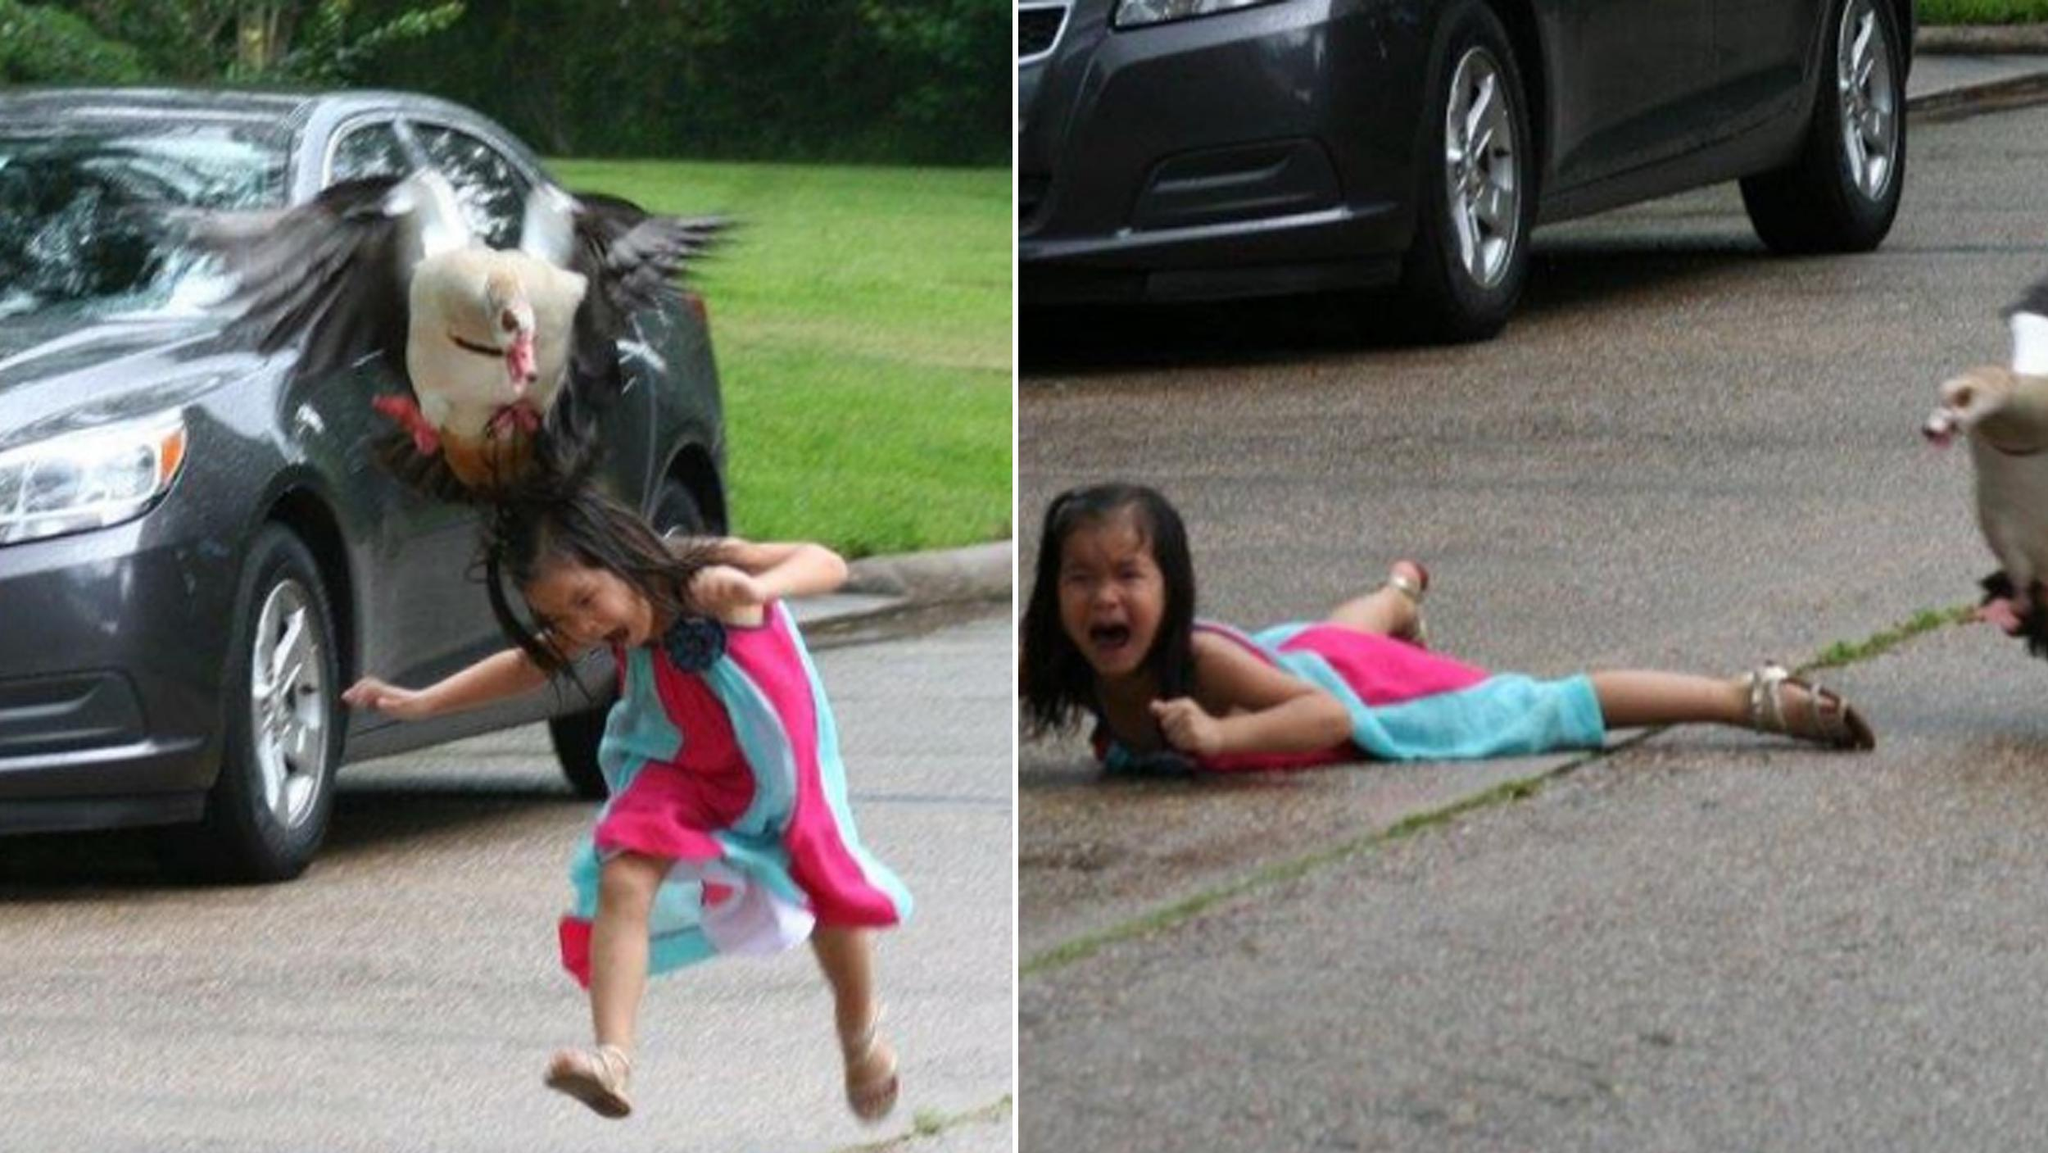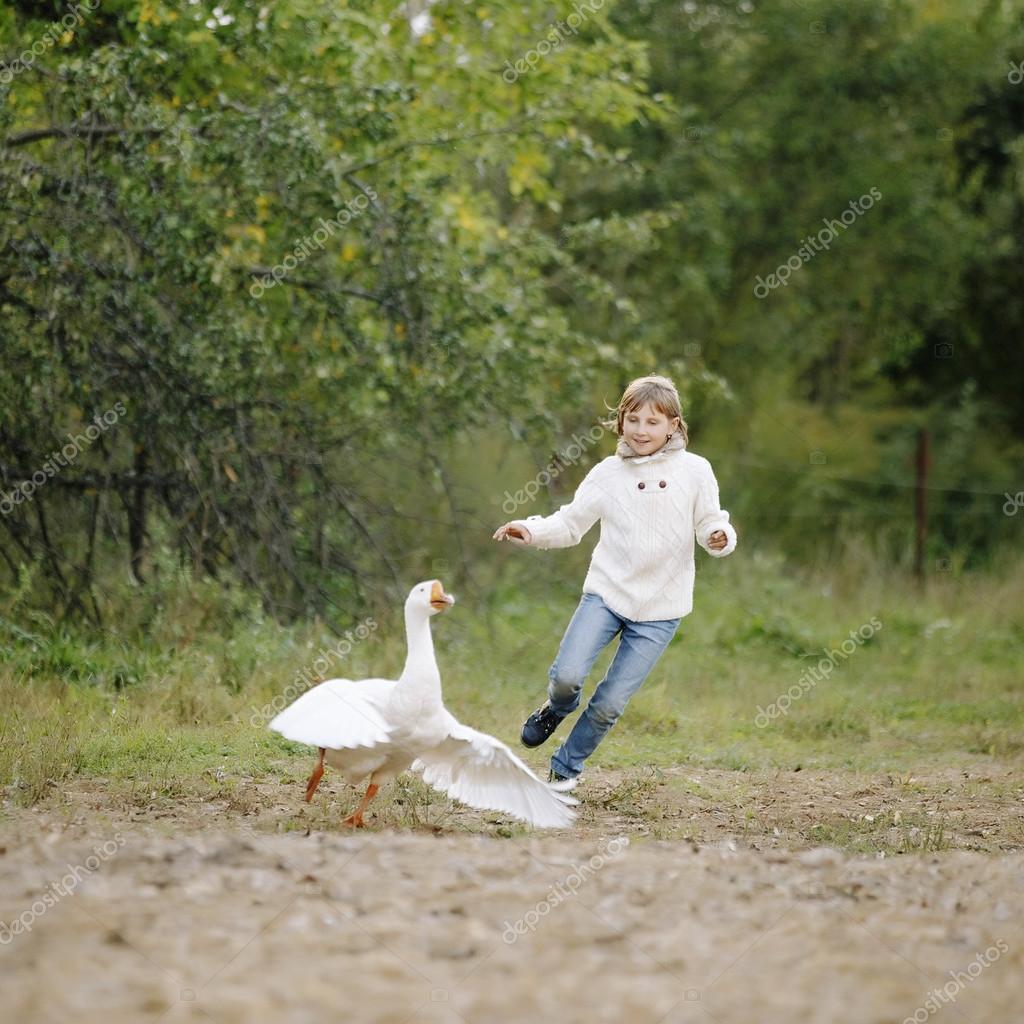The first image is the image on the left, the second image is the image on the right. For the images shown, is this caption "A child is playing outside with a single bird in one of the images." true? Answer yes or no. Yes. The first image is the image on the left, the second image is the image on the right. Considering the images on both sides, is "An image contains a goose attacking a child." valid? Answer yes or no. Yes. 